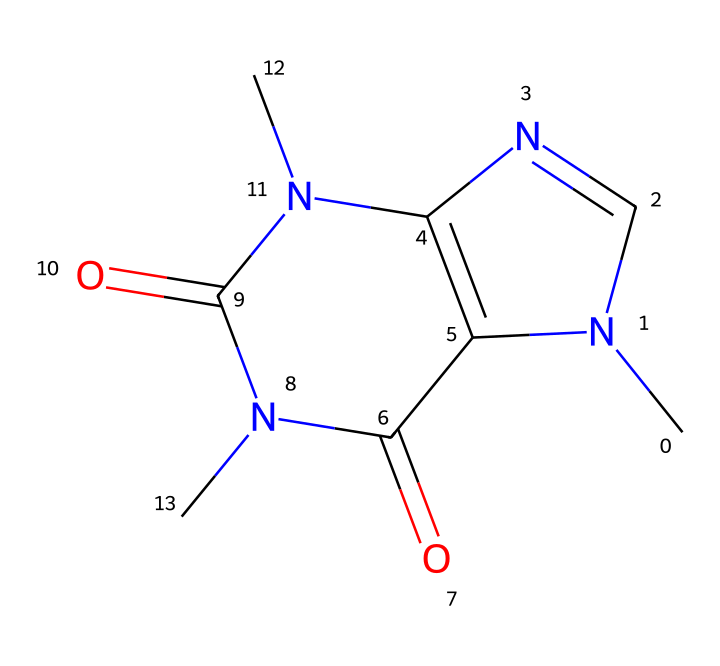What is the molecular formula for caffeine based on its SMILES representation? By analyzing the SMILES representation, we can identify the number of carbon (C), hydrogen (H), nitrogen (N), and oxygen (O) atoms present in the structure. This leads to a count of 8 carbons, 10 hydrogens, 4 nitrogens, and 2 oxygens, resulting in the molecular formula C8H10N4O2.
Answer: C8H10N4O2 How many nitrogen atoms are present in this caffeine structure? The SMILES representation contains a total of four nitrogen atoms (N) which can be counted based on their occurrences in the depicted structure.
Answer: 4 What type of compound is caffeine classified as? Caffeine is classified as a methylxanthine, which is a specific subclass of alkaloids characterized by their nitrogen-containing structure. This can be inferred from the presence of nitrogen and the particular ring structure seen in this compound.
Answer: methylxanthine What is the total number of rings present in the caffeine structure? Upon examining the structure represented, there are two fused rings visible, which are typical in cage compounds like caffeine. Thus, the total number of rings is two.
Answer: 2 What is the hybridization of the nitrogen atoms in caffeine? The nitrogen atoms in this structure are typically sp2 hybridized due to their bonding with carbon atoms in the aromatic and non-aromatic portions of the rings, where they typically participate in resonance.
Answer: sp2 What type of bond is primarily responsible for the stability of the caffeine molecule's ring structure? The stability in caffeine's ring structure is primarily due to delocalized pi bonds, which occur when there is resonance within the fused ring system. This type of bonding is common in aromatic compounds.
Answer: delocalized pi bonds 